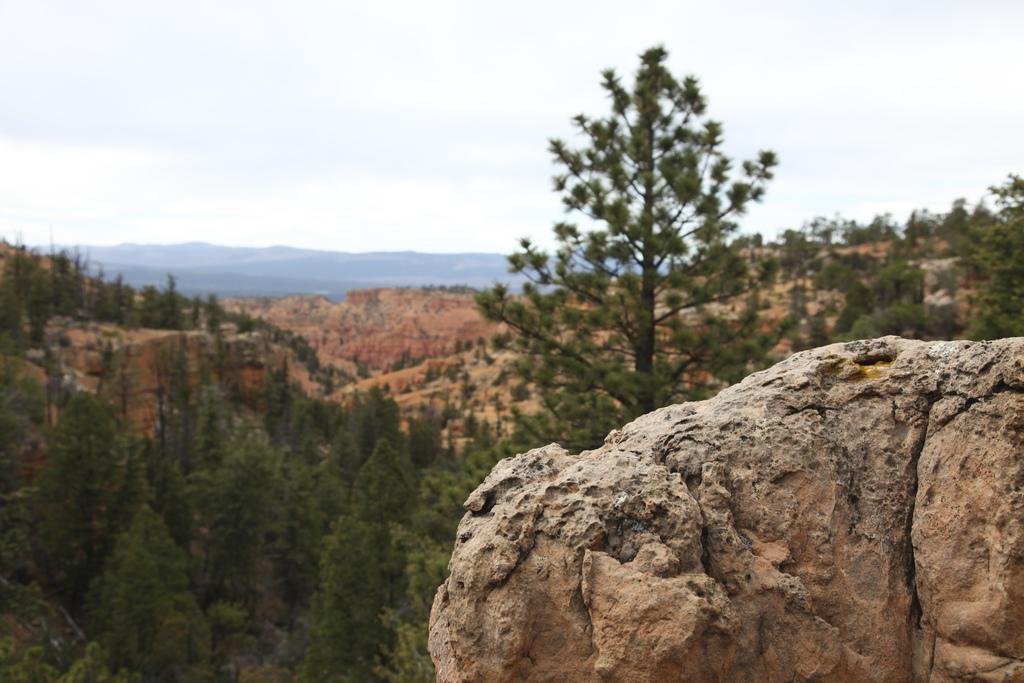Could you give a brief overview of what you see in this image? In the picture I can see the rock on the right side. In the background, I can see the hills and trees. There are clouds in the sky. 